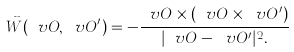<formula> <loc_0><loc_0><loc_500><loc_500>\vec { W } ( \ v O , \ v O ^ { \prime } ) = - \frac { \ v O \times ( \ v O \times \ v O ^ { \prime } ) } { | \ v O - \ v O ^ { \prime } | ^ { 2 } . }</formula> 